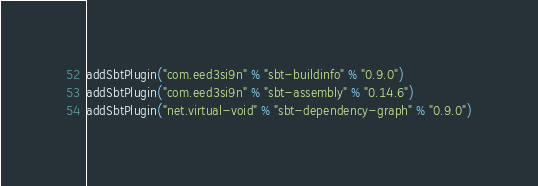Convert code to text. <code><loc_0><loc_0><loc_500><loc_500><_Scala_>addSbtPlugin("com.eed3si9n" % "sbt-buildinfo" % "0.9.0")
addSbtPlugin("com.eed3si9n" % "sbt-assembly" % "0.14.6")
addSbtPlugin("net.virtual-void" % "sbt-dependency-graph" % "0.9.0")
</code> 